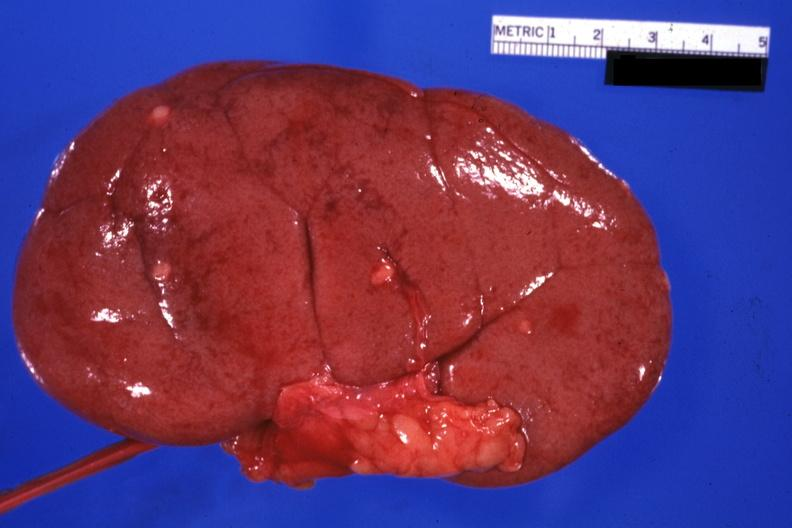what removed small lesions easily seen?
Answer the question using a single word or phrase. External view with capsule 